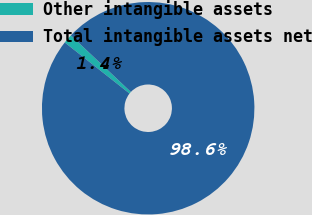Convert chart. <chart><loc_0><loc_0><loc_500><loc_500><pie_chart><fcel>Other intangible assets<fcel>Total intangible assets net<nl><fcel>1.4%<fcel>98.6%<nl></chart> 